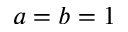<formula> <loc_0><loc_0><loc_500><loc_500>a = b = 1</formula> 